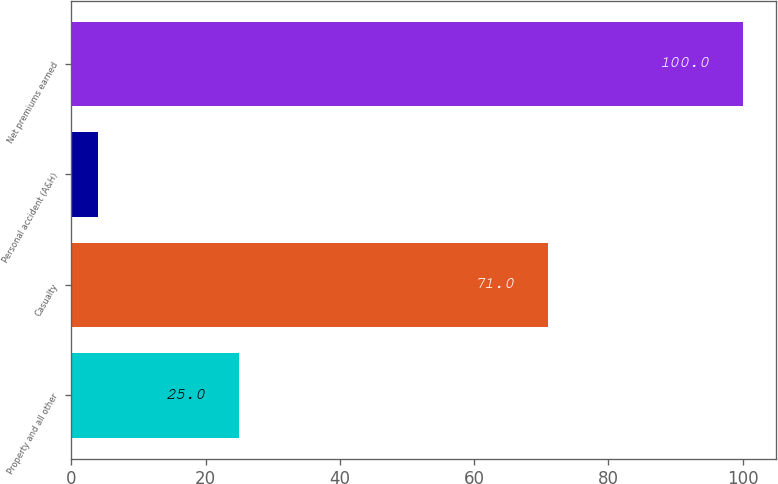<chart> <loc_0><loc_0><loc_500><loc_500><bar_chart><fcel>Property and all other<fcel>Casualty<fcel>Personal accident (A&H)<fcel>Net premiums earned<nl><fcel>25<fcel>71<fcel>4<fcel>100<nl></chart> 